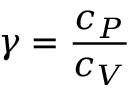Convert formula to latex. <formula><loc_0><loc_0><loc_500><loc_500>\gamma = { \frac { c _ { P } } { c _ { V } } }</formula> 